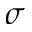Convert formula to latex. <formula><loc_0><loc_0><loc_500><loc_500>\sigma</formula> 